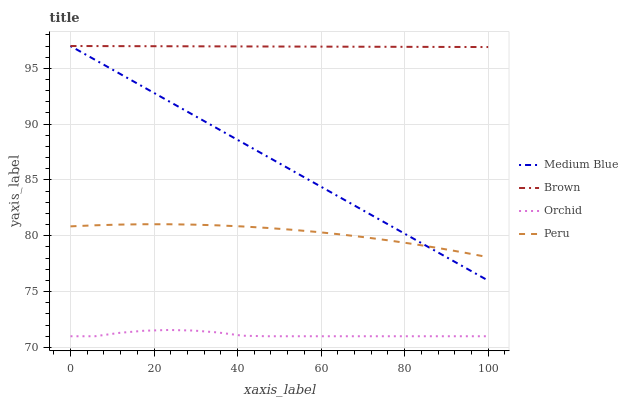Does Orchid have the minimum area under the curve?
Answer yes or no. Yes. Does Brown have the maximum area under the curve?
Answer yes or no. Yes. Does Medium Blue have the minimum area under the curve?
Answer yes or no. No. Does Medium Blue have the maximum area under the curve?
Answer yes or no. No. Is Brown the smoothest?
Answer yes or no. Yes. Is Orchid the roughest?
Answer yes or no. Yes. Is Medium Blue the smoothest?
Answer yes or no. No. Is Medium Blue the roughest?
Answer yes or no. No. Does Orchid have the lowest value?
Answer yes or no. Yes. Does Medium Blue have the lowest value?
Answer yes or no. No. Does Medium Blue have the highest value?
Answer yes or no. Yes. Does Peru have the highest value?
Answer yes or no. No. Is Orchid less than Medium Blue?
Answer yes or no. Yes. Is Medium Blue greater than Orchid?
Answer yes or no. Yes. Does Peru intersect Medium Blue?
Answer yes or no. Yes. Is Peru less than Medium Blue?
Answer yes or no. No. Is Peru greater than Medium Blue?
Answer yes or no. No. Does Orchid intersect Medium Blue?
Answer yes or no. No. 